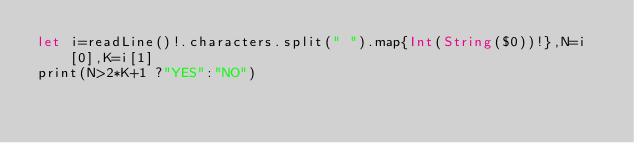Convert code to text. <code><loc_0><loc_0><loc_500><loc_500><_Swift_>let i=readLine()!.characters.split(" ").map{Int(String($0))!},N=i[0],K=i[1]
print(N>2*K+1 ?"YES":"NO")</code> 